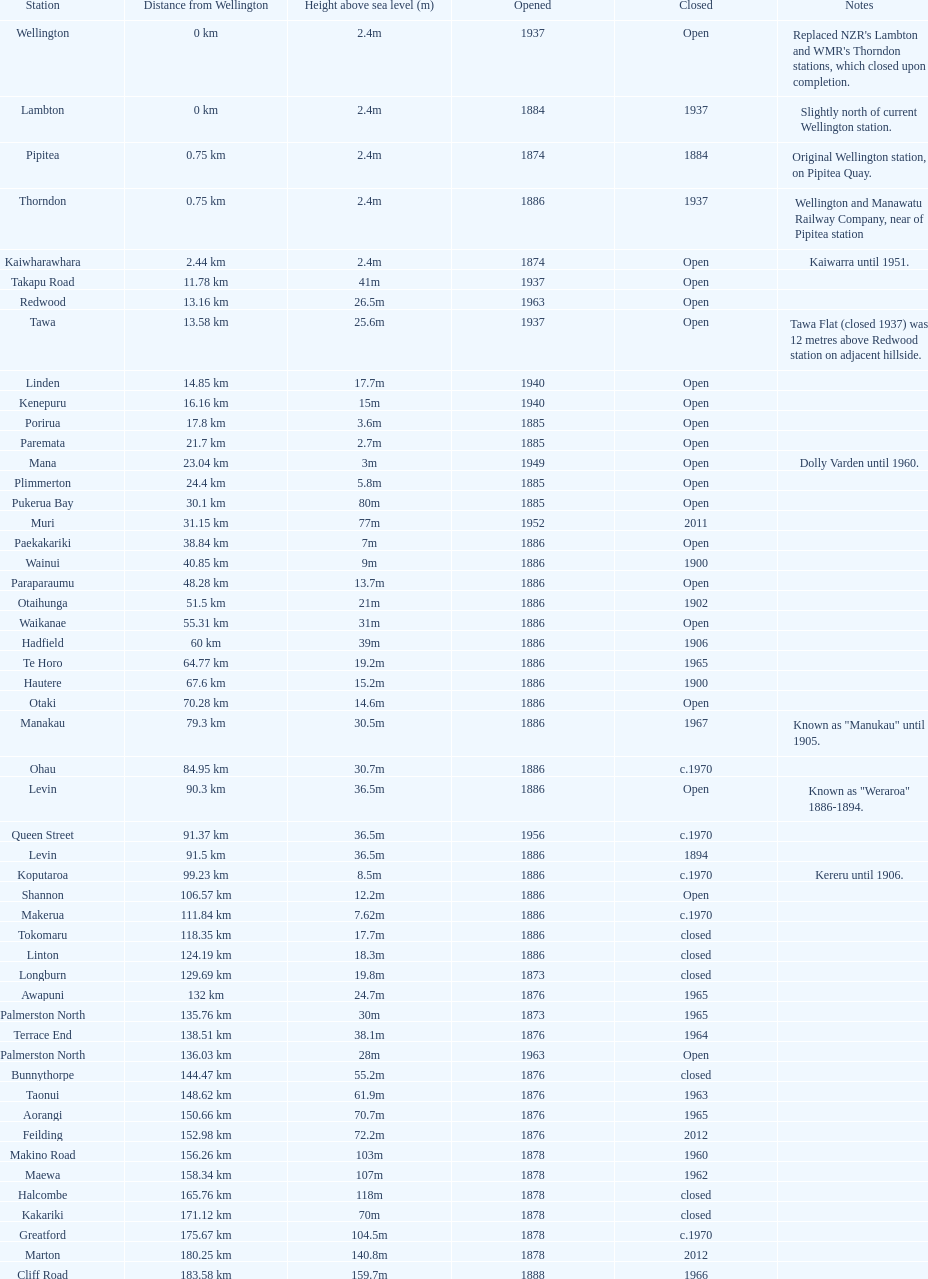How much higher is the takapu road station than the wellington station? 38.6m. Can you give me this table as a dict? {'header': ['Station', 'Distance from Wellington', 'Height above sea level (m)', 'Opened', 'Closed', 'Notes'], 'rows': [['Wellington', '0\xa0km', '2.4m', '1937', 'Open', "Replaced NZR's Lambton and WMR's Thorndon stations, which closed upon completion."], ['Lambton', '0\xa0km', '2.4m', '1884', '1937', 'Slightly north of current Wellington station.'], ['Pipitea', '0.75\xa0km', '2.4m', '1874', '1884', 'Original Wellington station, on Pipitea Quay.'], ['Thorndon', '0.75\xa0km', '2.4m', '1886', '1937', 'Wellington and Manawatu Railway Company, near of Pipitea station'], ['Kaiwharawhara', '2.44\xa0km', '2.4m', '1874', 'Open', 'Kaiwarra until 1951.'], ['Takapu Road', '11.78\xa0km', '41m', '1937', 'Open', ''], ['Redwood', '13.16\xa0km', '26.5m', '1963', 'Open', ''], ['Tawa', '13.58\xa0km', '25.6m', '1937', 'Open', 'Tawa Flat (closed 1937) was 12 metres above Redwood station on adjacent hillside.'], ['Linden', '14.85\xa0km', '17.7m', '1940', 'Open', ''], ['Kenepuru', '16.16\xa0km', '15m', '1940', 'Open', ''], ['Porirua', '17.8\xa0km', '3.6m', '1885', 'Open', ''], ['Paremata', '21.7\xa0km', '2.7m', '1885', 'Open', ''], ['Mana', '23.04\xa0km', '3m', '1949', 'Open', 'Dolly Varden until 1960.'], ['Plimmerton', '24.4\xa0km', '5.8m', '1885', 'Open', ''], ['Pukerua Bay', '30.1\xa0km', '80m', '1885', 'Open', ''], ['Muri', '31.15\xa0km', '77m', '1952', '2011', ''], ['Paekakariki', '38.84\xa0km', '7m', '1886', 'Open', ''], ['Wainui', '40.85\xa0km', '9m', '1886', '1900', ''], ['Paraparaumu', '48.28\xa0km', '13.7m', '1886', 'Open', ''], ['Otaihunga', '51.5\xa0km', '21m', '1886', '1902', ''], ['Waikanae', '55.31\xa0km', '31m', '1886', 'Open', ''], ['Hadfield', '60\xa0km', '39m', '1886', '1906', ''], ['Te Horo', '64.77\xa0km', '19.2m', '1886', '1965', ''], ['Hautere', '67.6\xa0km', '15.2m', '1886', '1900', ''], ['Otaki', '70.28\xa0km', '14.6m', '1886', 'Open', ''], ['Manakau', '79.3\xa0km', '30.5m', '1886', '1967', 'Known as "Manukau" until 1905.'], ['Ohau', '84.95\xa0km', '30.7m', '1886', 'c.1970', ''], ['Levin', '90.3\xa0km', '36.5m', '1886', 'Open', 'Known as "Weraroa" 1886-1894.'], ['Queen Street', '91.37\xa0km', '36.5m', '1956', 'c.1970', ''], ['Levin', '91.5\xa0km', '36.5m', '1886', '1894', ''], ['Koputaroa', '99.23\xa0km', '8.5m', '1886', 'c.1970', 'Kereru until 1906.'], ['Shannon', '106.57\xa0km', '12.2m', '1886', 'Open', ''], ['Makerua', '111.84\xa0km', '7.62m', '1886', 'c.1970', ''], ['Tokomaru', '118.35\xa0km', '17.7m', '1886', 'closed', ''], ['Linton', '124.19\xa0km', '18.3m', '1886', 'closed', ''], ['Longburn', '129.69\xa0km', '19.8m', '1873', 'closed', ''], ['Awapuni', '132\xa0km', '24.7m', '1876', '1965', ''], ['Palmerston North', '135.76\xa0km', '30m', '1873', '1965', ''], ['Terrace End', '138.51\xa0km', '38.1m', '1876', '1964', ''], ['Palmerston North', '136.03\xa0km', '28m', '1963', 'Open', ''], ['Bunnythorpe', '144.47\xa0km', '55.2m', '1876', 'closed', ''], ['Taonui', '148.62\xa0km', '61.9m', '1876', '1963', ''], ['Aorangi', '150.66\xa0km', '70.7m', '1876', '1965', ''], ['Feilding', '152.98\xa0km', '72.2m', '1876', '2012', ''], ['Makino Road', '156.26\xa0km', '103m', '1878', '1960', ''], ['Maewa', '158.34\xa0km', '107m', '1878', '1962', ''], ['Halcombe', '165.76\xa0km', '118m', '1878', 'closed', ''], ['Kakariki', '171.12\xa0km', '70m', '1878', 'closed', ''], ['Greatford', '175.67\xa0km', '104.5m', '1878', 'c.1970', ''], ['Marton', '180.25\xa0km', '140.8m', '1878', '2012', ''], ['Cliff Road', '183.58\xa0km', '159.7m', '1888', '1966', ''], ['Overton', '188.85\xa0km', '155m', '1888', '1958', ''], ['Porewa', '190.53\xa0km', '165m', '1888', 'closed', ''], ['Rata', '195.46\xa0km', '194m', '1888', '1975', ''], ['Silverhope', '199.31\xa0km', '224m', '1888', '1966', ''], ['Hunterville', '205.33\xa0km', '267m', '1888', '1986', ''], ['Kaikarangi', '210.18\xa0km', '284m', '1888', '1964', ''], ['Mangaonoho', '216.04\xa0km', '257m', '1893', '1966', ''], ['Ohingaiti', '222.14\xa0km', '279m', '1902', '1975', ''], ['Mangaweka', '231.04\xa0km', '326.7m', '1902', '1982', ''], ['Utiku', '243.69\xa0km', '371m', '1904', 'closed', ''], ['Ohotu', '247.08\xa0km', '395.6m', '1904', 'closed', ''], ['Winiata', '249.02\xa0km', '415m', '1904', 'closed', ''], ['Taihape', '251.85\xa0km', '442m', '1904', '2012', ''], ['Mataroa', '260.88\xa0km', '530m', '1907', 'closed', ''], ['Ngaurukehu', '270.25\xa0km', '640m', '1908', 'closed', ''], ['Turangarere', '274.5\xa0km', '702m', '1912', '1972', ''], ['Hihitahi', '278.2\xa0km', '741m', '1908', 'closed', 'Turangarere until 1912. "Hihitahi" is a sound-based local Maori word for "locomotive".'], ['Waiouru', '290.3\xa0km', '813.8m', '1908', '2005', 'Highest railway station in New Zealand.'], ['Tangiwai', '299.49\xa0km', '699.5m', '1909', 'closed', 'Nearest station to the Tangiwai disaster, December 24, 1953.'], ['Karioi', '306.94\xa0km', '630.3m', '1909', 'closed', ''], ['Rangataua', '312.79\xa0km', '670m', '1909', 'closed', ''], ['Ohakune', '317.09\xa0km', '618.4m', '1908', 'open', 'Ohakune Junction in working timetables 1917-1968.'], ['Horopito', '326.91\xa0km', '752m', '1909', '1981', 'Used as location for Smash Palace movie, 1981'], ['Pokaka', '332.57\xa0km', '811m', '1909', 'closed', ''], ['Erua', '340.13\xa0km', '742.5m', '1908', 'closed', ''], ['National Park', '346.83\xa0km', '806.8m', '1908', 'open', 'Waimarino until 1949.'], ['Raurimu', '358.31\xa0km', '589m', '1908', 'closed', ''], ['Oio', '366.25\xa0km', '520m', '1908', 'closed', 'Known to WW2 American servicemen as "Zero-10". Shortest station name in the North Island, with Ava.'], ['Owhango', '371.89\xa0km', '456.6m', '1908', 'closed', ''], ['Kakahi', '382\xa0km', '266m', '1908', 'closed', ''], ['Piriaka', '387.15\xa0km', '230m', '1908', 'closed', ''], ['Manunui', '391.9\xa0km', '190.5m', '1908', 'closed', ''], ['Matapuna', '394.8\xa0km', '180m', '1908', 'closed', ''], ['Taumarunui', '397.75\xa0km', '171m', '1903', '2012', ''], ['Taringamotu', '402\xa0km', '172.5m', '1903', '1971', ''], ['Okahukura', '408.54', '178.3m', '1903', 'closed', 'Okahukura Junction in working timetables 1933-2010.'], ['Te Koura', '412.75\xa0km', '182m', '1909', '1975', ''], ['Ongarue', '420.68\xa0km', '192.6m', '1903', '1986', ''], ['Waione Siding', '426.86\xa0km', '208m', '1921', '1950', ''], ['Waimiha', '434.39\xa0km', '232m', '1903', '1983', ''], ['Poro-O-Tarao', '444.05\xa0km', '339.2m', '1901', '1979', ''], ['Mangapehi', '449.47\xa0km', '285.3m', '1901', '1984', 'Known as "Mangapeehi" station 1901-1920.'], ['Kopaki', '454.35\xa0km', '265m', '1901', 'closed', 'Paratikana until 1920.'], ['Puketutu', '461.83\xa0km', '206m', '1889', 'closed', 'Mokau" until 1912.'], ['Waiteti', '470.07\xa0km', '135m', '1889', 'closed', ''], ['Te Kuiti', '475.66\xa0km', '54m', '1887', '2012', ''], ['Te Kumi', '478.56\xa0km', '49.6m', '1887', 'closed', ''], ['Hangatiki', '485.2\xa0km', '39.9m', '1887', 'closed', ''], ['Otorohonga', '494.41\xa0km', '37m', '1887', '2012', 'Reopened summer 2012'], ['Kiokio', '498.45\xa0km', '35.4m', '1887', '1973', ''], ['Te Kawa', '506.88\xa0km', '47.8m', '1887', '1982', ''], ['Te Mawhai', '513\xa0km', '35.6m', '1887', '1958', 'Te Puhi until 1900'], ['Te Awamutu', '517.02\xa0km', '50m', '1880', '2005', 'New Zealand Dairy Board (now Fonterra) rebuilt its freight connection about 2000.'], ['Ngaroto', '519.92\xa0km', '56m', '1880', '1954', ''], ['Lake Road', '522.26\xa0km', '54m', '1880', 'closed', ''], ['Ohaupo', '527.16\xa0km', '52m', '1880', '1982', ''], ['Rukuhia', '533.59\xa0km', '55m', '1880', '1970', ''], ['Hamilton', '542.52\xa0km', '37.5m', '1877', 'Open', 'Previously Hamilton Junction and Frankton Junction.'], ['Te Rapa Racecourse', '547.50\xa0km', '33.2m', '1920', '1980', ''], ['Te Rapa', '549.25\xa0km', '33m', '1877', '1970', 'Not to be confused with Te Rapa Marshalling Yards (547\xa0km from Wellington).'], ['Horotiu', '553.65\xa0km', '23.7m', '1877', 'c1968', 'Pukete until 1920'], ['Ngaruawahia', '559.16\xa0km', '20.7m', '1877', 'c1968', 'Newcastle until 1895.'], ['Taupiri', '566.56\xa0km', '13.7m', '1877', 'c1968', ''], ['Huntly', '573.87\xa0km', '14m', '1877', '1998', ''], ['Kimihia', '578.45\xa0km', '14m', '1877', '1948', ''], ['Ohinewai', '582.04\xa0km', '10m', '1877', 'c1968', ''], ['Rangiriri', '588.11', '9m', '1877', '1957', ''], ['Te Kauwhata', '591.62\xa0km', '12.2m', '1877', '1984', ''], ['Whangamarino', '598.34\xa0km', '6.7m', '1877', '1978', ''], ['Amokura', '604.53\xa0km', '7m', '1877', '1980', ''], ['Mercer', '609.16\xa0km', '6.4m', '1877', '1986', ''], ['Pokeno', '613.96\xa0km', '24m', '1877', 'c1968', ''], ['Whangarata', '617.90\xa0km', '59.7m', '1877', 'c1968', ''], ['Tuakau', '621.41\xa0km', '37m', '1875', '1986', ''], ['Buckland', '625.6\xa0km', '58m', '1875', 'closed', ''], ['Pukekohe', '628.86\xa0km', '60.65m', '1875', 'open', ''], ['Paerata', '633.29\xa0km', '45.1m', '1875', '1980', 'Paerata Junction from 1917.'], ['Runciman', '638.37\xa0km', '8m', '1875', '1939', ''], ['Drury', '640\xa0km', '9m', '1875', '1980', ''], ['Opaheke', '642.9\xa0km', '14.5m', '1875', '1955', 'Hunua 1877-1939.'], ['Papakura', '647.02\xa0km', '19.2m', '1875', 'Open', ''], ['Tironui', '648.95\xa0km', '15.5m', '1904', '1980', ''], ['Takanini', '650.64\xa0km', '15.2m', '1875', 'Open', ''], ['Te Mahia', '652.24\xa0km', '14.9m', '1904', 'Open', ''], ['Manurewa', '653.1\xa0km', '17m', '1875', 'Open', ''], ['Homai', '655.7\xa0km', '30.78m', '1904', 'Open', ''], ['Wiri', '657.6\xa0km', '22.25m', '1913', '2005', ''], ['Puhinui', '658.92\xa0km', '19.8m', '1904', 'Open', ''], ['Papatoitoi', '659.63\xa0km', '18.9m', '1875', '1904', ''], ['Papatoetoe', '660.42\xa0km', '18m', '1904', 'Open', ''], ['Middlemore', '662.28\xa0km', '8.8m', '1904', 'Open', ''], ['Mangere', '663.02\xa0km', '10.66m', '1904', '2011', ''], ['Otahuhu', '664.15\xa0km', '9.44m', '1875', 'Open', ''], ['Westfield', '665.5\xa0km', '7.6m', '1904', 'Open', ''], ['Sylvia Park', '667.09\xa0km', '7.6m', '1931', 'Open', 'Relocated 1\xa0km further north, 2007.'], ['Panmure', '669.93\xa0km', '17.7m', '1931', 'Open', 'Relocated 200m north, 2007.'], ['Tamaki', '671.28\xa0km', '23.5m', '1930', '1980', ''], ['Glen Innes', '672.64\xa0km', '22m', '1930', 'Open', ''], ['Purewa', '675.4\xa0km', '18m', '1930', '1955', ''], ['Meadowbank', '676.26\xa0km', '12m', '1954', 'Open', ''], ['Orakei', '677.44\xa0km', '4.5m', '1930', 'Open', ''], ['The Strand', '680.76\xa0km', '2.7m', '1930', 'Open', 'Was platform 7 (later platform 4) of 1930-2003 Auckland station. Used for steam services.'], ['Britomart Transport Centre', '682\xa0km', '4m below sea level', '2003', 'Open', '']]} 